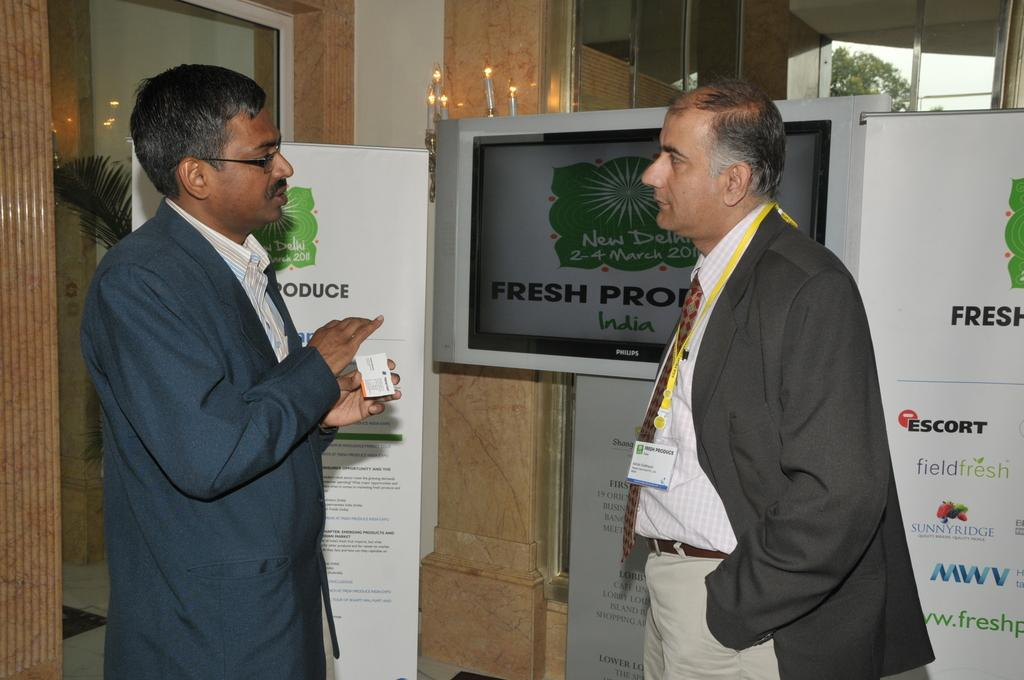How many people are present in the image? There are two persons standing in the image. What is one of the persons holding? One of the persons is holding a card. What type of structures can be seen in the image? There are boards and glass walls in the image. What type of electronic device is present in the image? There is a monitor in the image. What type of vegetation can be seen in the image? There is a plant and a tree in the image. What part of the natural environment is visible in the image? The sky is visible in the image. What type of mitten is being used to draw attention to the society in the image? There is no mitten or society present in the image. 